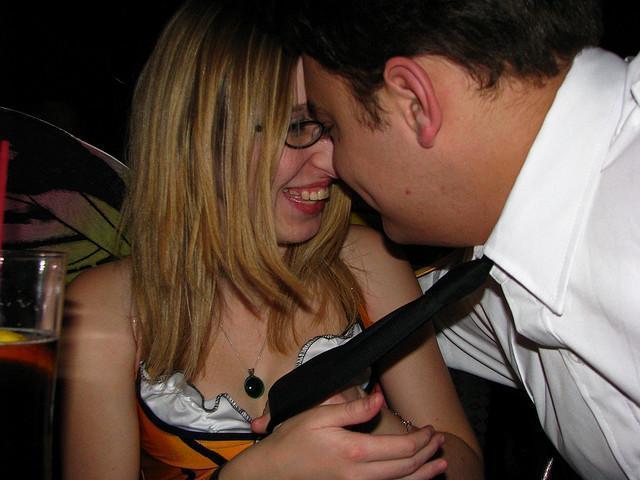How many people are in the photo?
Give a very brief answer. 2. How many people are there?
Give a very brief answer. 2. 